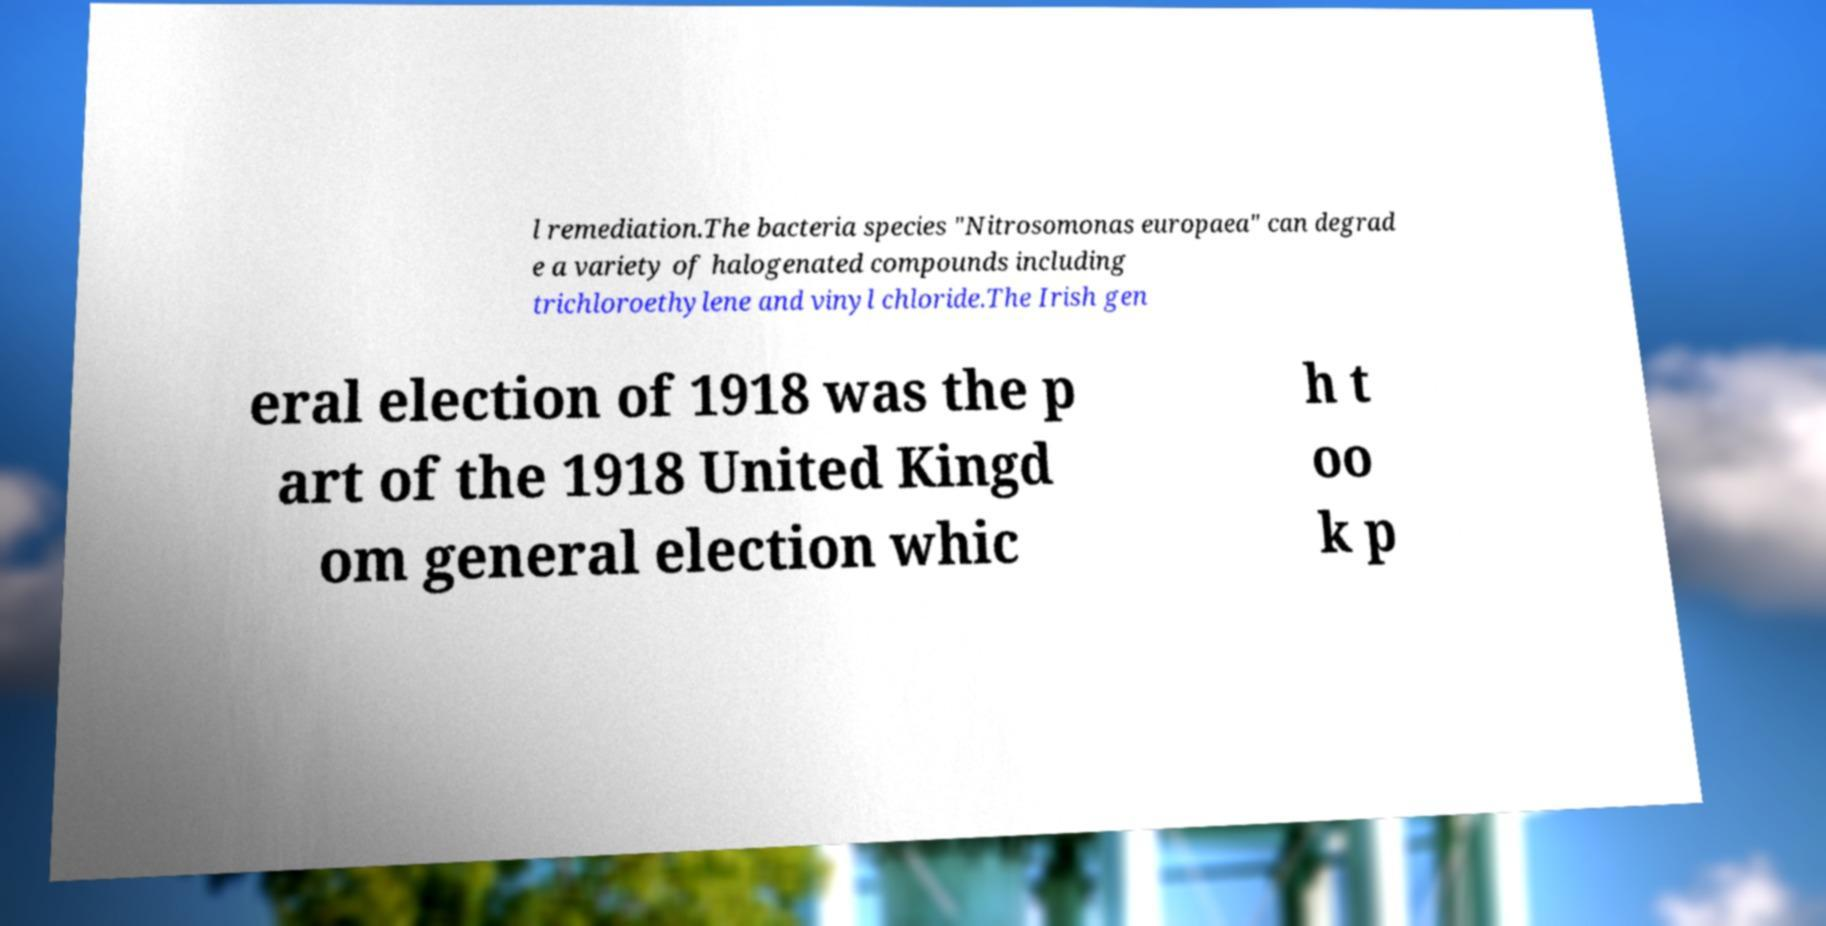Can you accurately transcribe the text from the provided image for me? l remediation.The bacteria species "Nitrosomonas europaea" can degrad e a variety of halogenated compounds including trichloroethylene and vinyl chloride.The Irish gen eral election of 1918 was the p art of the 1918 United Kingd om general election whic h t oo k p 